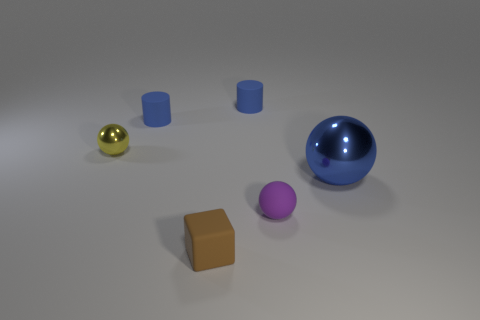Add 2 big blue shiny objects. How many objects exist? 8 Subtract all blocks. How many objects are left? 5 Add 1 tiny blue metal blocks. How many tiny blue metal blocks exist? 1 Subtract 0 green blocks. How many objects are left? 6 Subtract all small green blocks. Subtract all blue metallic objects. How many objects are left? 5 Add 6 metal spheres. How many metal spheres are left? 8 